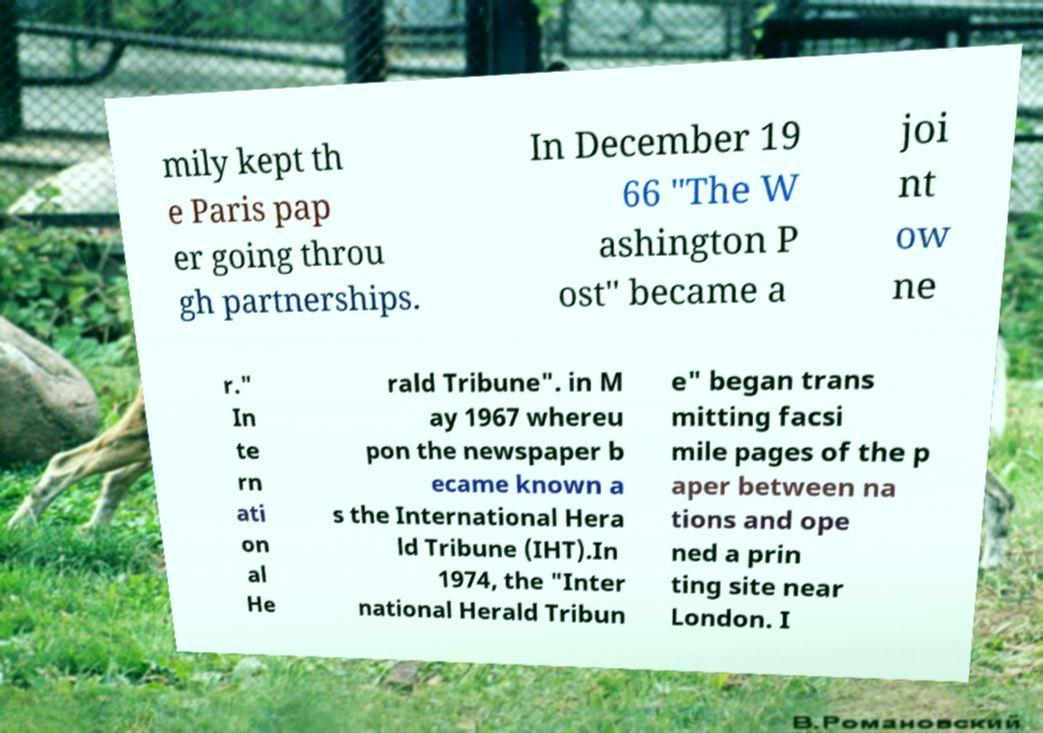For documentation purposes, I need the text within this image transcribed. Could you provide that? mily kept th e Paris pap er going throu gh partnerships. In December 19 66 "The W ashington P ost" became a joi nt ow ne r." In te rn ati on al He rald Tribune". in M ay 1967 whereu pon the newspaper b ecame known a s the International Hera ld Tribune (IHT).In 1974, the "Inter national Herald Tribun e" began trans mitting facsi mile pages of the p aper between na tions and ope ned a prin ting site near London. I 